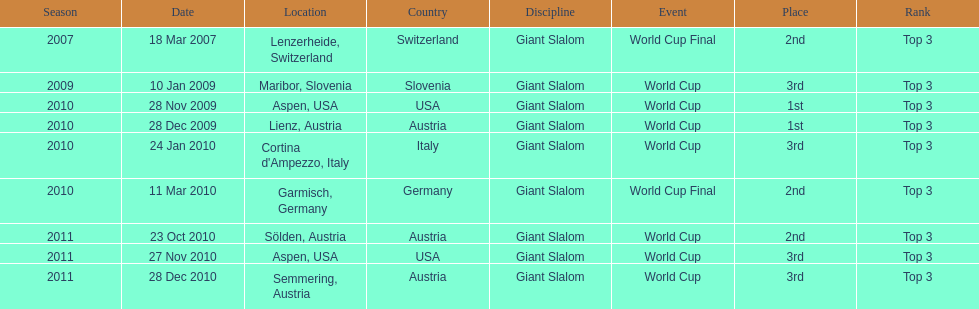The final race finishing place was not 1st but what other place? 3rd. 